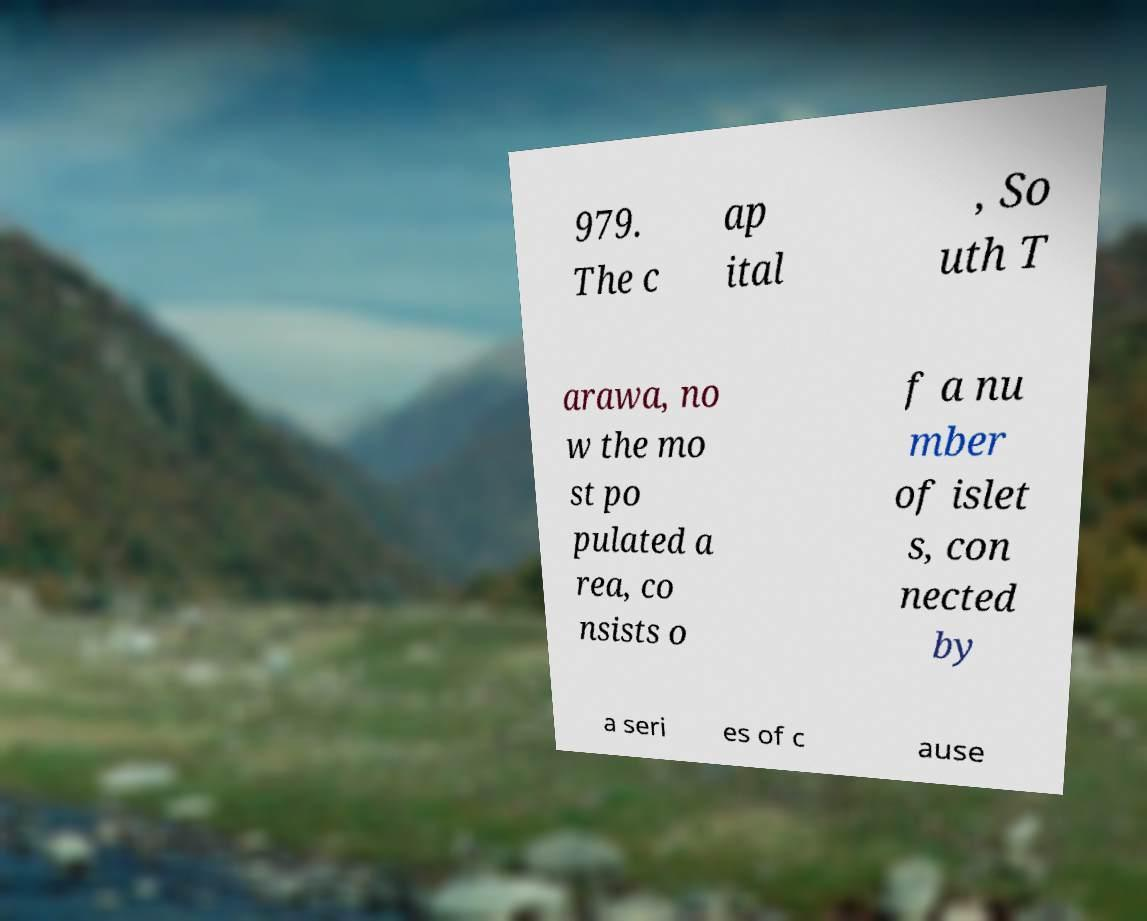Please identify and transcribe the text found in this image. 979. The c ap ital , So uth T arawa, no w the mo st po pulated a rea, co nsists o f a nu mber of islet s, con nected by a seri es of c ause 